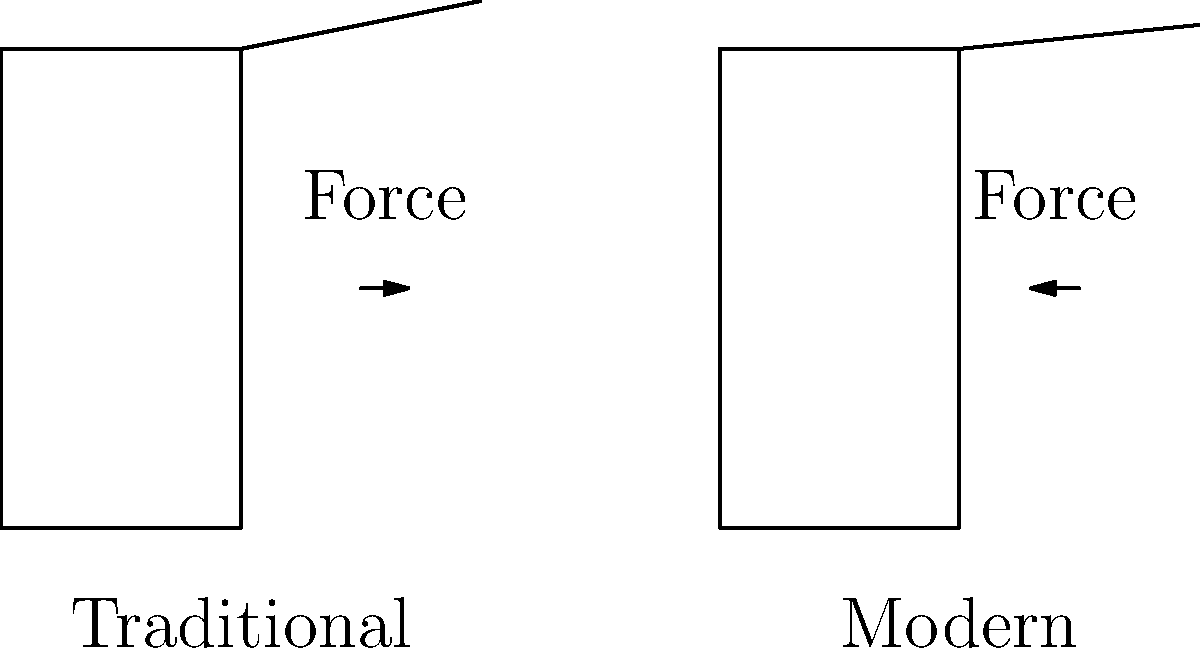Based on the simple line drawings of traditional and modern lacrosse stick designs, which design is likely to provide better biomechanical efficiency for players, and why? To analyze the biomechanical efficiency of the two lacrosse stick designs, we need to consider several factors:

1. Stick head angle:
   - Traditional: The stick head is more angled (steeper).
   - Modern: The stick head has a shallower angle.

2. Force application:
   - Traditional: The force arrow is longer, indicating more force needed.
   - Modern: The force arrow is shorter, suggesting less force required.

3. Lever principle:
   - Traditional: The longer, more angled head creates a longer lever arm.
   - Modern: The shorter, less angled head results in a shorter lever arm.

4. Energy transfer:
   - Traditional: More energy is lost due to the longer lever arm and steeper angle.
   - Modern: Less energy is lost, allowing for more efficient energy transfer.

5. Player effort:
   - Traditional: Requires more effort from the player to generate the same ball speed.
   - Modern: Requires less effort, allowing for quicker and more efficient movements.

The modern design's shallower angle and shorter lever arm result in:
a) Reduced energy loss during ball release
b) More efficient force transfer from the player to the ball
c) Quicker, more controlled movements

These factors contribute to better biomechanical efficiency for the player, allowing for improved performance with less physical strain.
Answer: Modern design; shorter lever arm and shallower angle improve force transfer and reduce energy loss. 